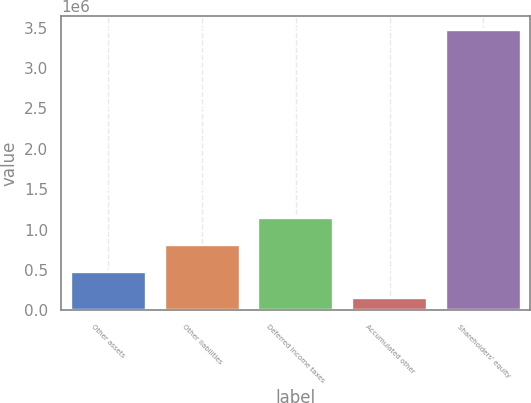Convert chart to OTSL. <chart><loc_0><loc_0><loc_500><loc_500><bar_chart><fcel>Other assets<fcel>Other liabilities<fcel>Deferred income taxes<fcel>Accumulated other<fcel>Shareholders' equity<nl><fcel>480922<fcel>812831<fcel>1.14474e+06<fcel>149012<fcel>3.46811e+06<nl></chart> 